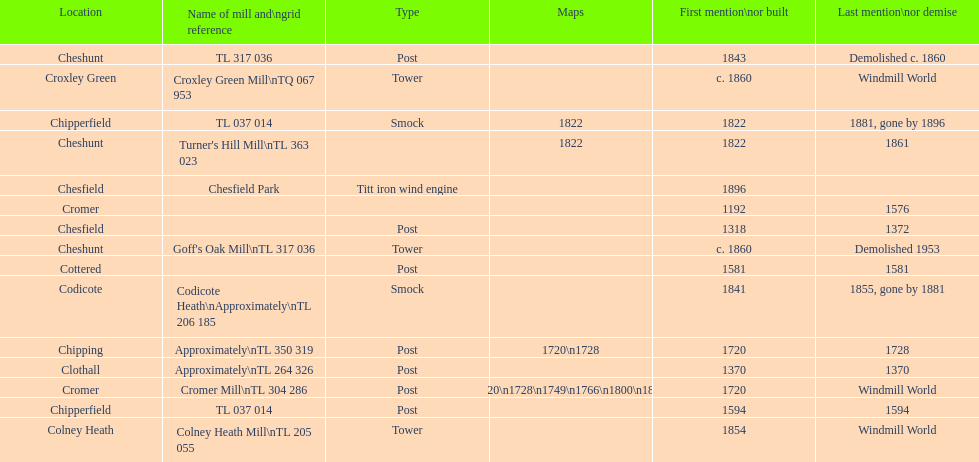Could you parse the entire table? {'header': ['Location', 'Name of mill and\\ngrid reference', 'Type', 'Maps', 'First mention\\nor built', 'Last mention\\nor demise'], 'rows': [['Cheshunt', 'TL 317 036', 'Post', '', '1843', 'Demolished c. 1860'], ['Croxley Green', 'Croxley Green Mill\\nTQ 067 953', 'Tower', '', 'c. 1860', 'Windmill World'], ['Chipperfield', 'TL 037 014', 'Smock', '1822', '1822', '1881, gone by 1896'], ['Cheshunt', "Turner's Hill Mill\\nTL 363 023", '', '1822', '1822', '1861'], ['Chesfield', 'Chesfield Park', 'Titt iron wind engine', '', '1896', ''], ['Cromer', '', '', '', '1192', '1576'], ['Chesfield', '', 'Post', '', '1318', '1372'], ['Cheshunt', "Goff's Oak Mill\\nTL 317 036", 'Tower', '', 'c. 1860', 'Demolished 1953'], ['Cottered', '', 'Post', '', '1581', '1581'], ['Codicote', 'Codicote Heath\\nApproximately\\nTL 206 185', 'Smock', '', '1841', '1855, gone by 1881'], ['Chipping', 'Approximately\\nTL 350 319', 'Post', '1720\\n1728', '1720', '1728'], ['Clothall', 'Approximately\\nTL 264 326', 'Post', '', '1370', '1370'], ['Cromer', 'Cromer Mill\\nTL 304 286', 'Post', '1720\\n1728\\n1749\\n1766\\n1800\\n1822', '1720', 'Windmill World'], ['Chipperfield', 'TL 037 014', 'Post', '', '1594', '1594'], ['Colney Heath', 'Colney Heath Mill\\nTL 205 055', 'Tower', '', '1854', 'Windmill World']]} How many mills were mentioned or built before 1700? 5. 